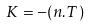Convert formula to latex. <formula><loc_0><loc_0><loc_500><loc_500>K = - ( n . T )</formula> 